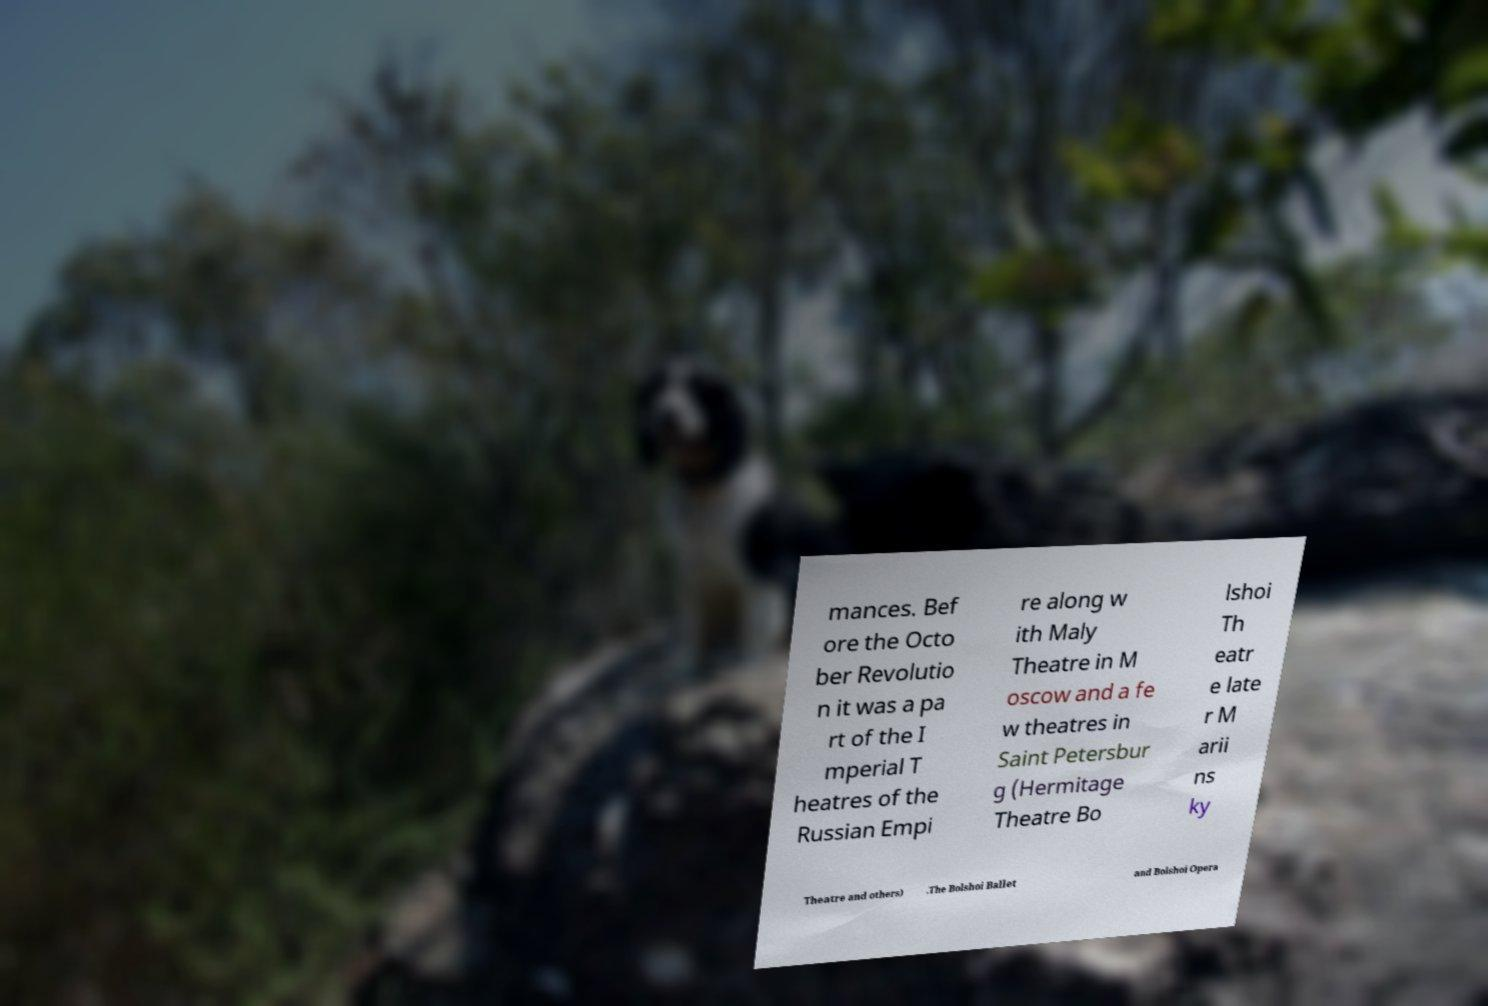What messages or text are displayed in this image? I need them in a readable, typed format. mances. Bef ore the Octo ber Revolutio n it was a pa rt of the I mperial T heatres of the Russian Empi re along w ith Maly Theatre in M oscow and a fe w theatres in Saint Petersbur g (Hermitage Theatre Bo lshoi Th eatr e late r M arii ns ky Theatre and others) .The Bolshoi Ballet and Bolshoi Opera 